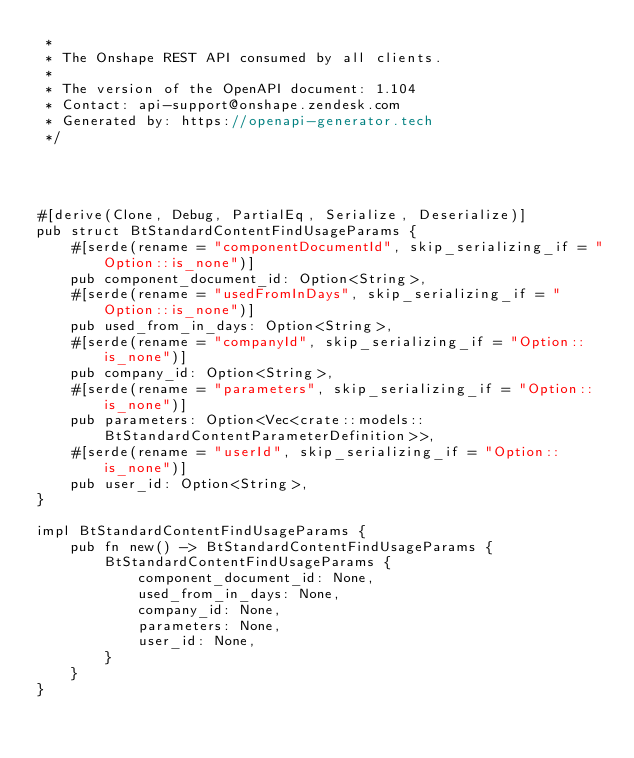<code> <loc_0><loc_0><loc_500><loc_500><_Rust_> *
 * The Onshape REST API consumed by all clients.
 *
 * The version of the OpenAPI document: 1.104
 * Contact: api-support@onshape.zendesk.com
 * Generated by: https://openapi-generator.tech
 */




#[derive(Clone, Debug, PartialEq, Serialize, Deserialize)]
pub struct BtStandardContentFindUsageParams {
    #[serde(rename = "componentDocumentId", skip_serializing_if = "Option::is_none")]
    pub component_document_id: Option<String>,
    #[serde(rename = "usedFromInDays", skip_serializing_if = "Option::is_none")]
    pub used_from_in_days: Option<String>,
    #[serde(rename = "companyId", skip_serializing_if = "Option::is_none")]
    pub company_id: Option<String>,
    #[serde(rename = "parameters", skip_serializing_if = "Option::is_none")]
    pub parameters: Option<Vec<crate::models::BtStandardContentParameterDefinition>>,
    #[serde(rename = "userId", skip_serializing_if = "Option::is_none")]
    pub user_id: Option<String>,
}

impl BtStandardContentFindUsageParams {
    pub fn new() -> BtStandardContentFindUsageParams {
        BtStandardContentFindUsageParams {
            component_document_id: None,
            used_from_in_days: None,
            company_id: None,
            parameters: None,
            user_id: None,
        }
    }
}


</code> 